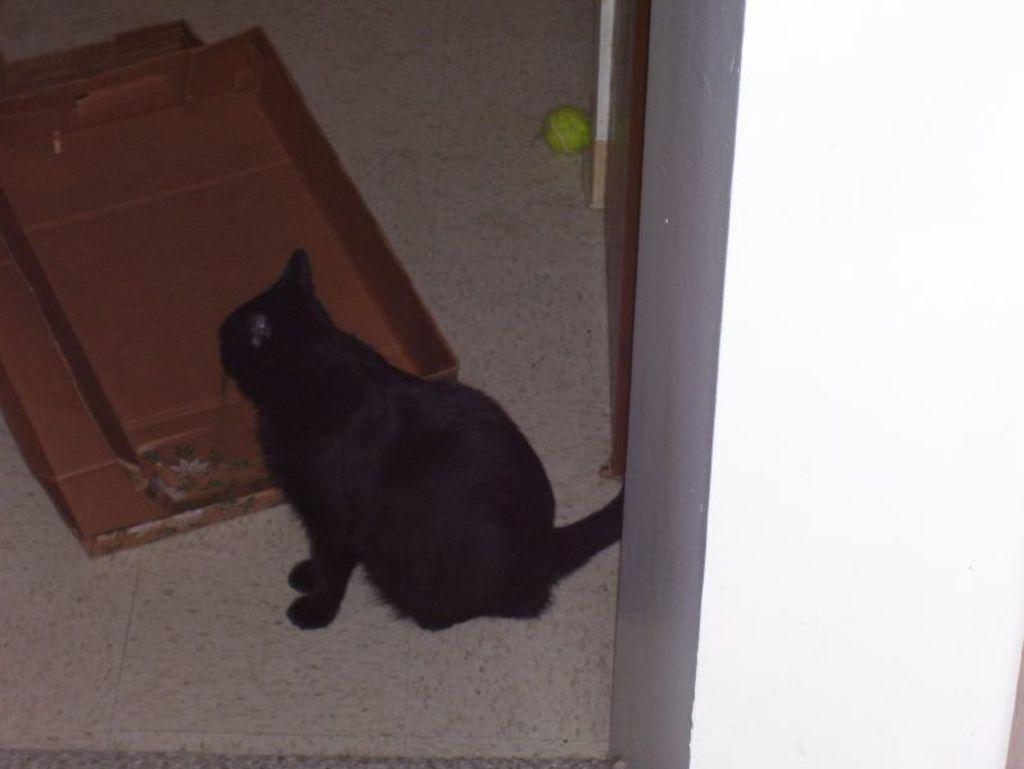What type of animal is in the image? There is a black color cat in the image. What is on the right side of the image? There is a wall on the right side of the image. What is on the left side of the image? There is a cardboard box on the left side of the image. What object can be seen in the background of the image? There is a tennis ball in the background of the image. How does the fog affect the visibility of the cat in the image? There is no fog present in the image, so it does not affect the visibility of the cat. 